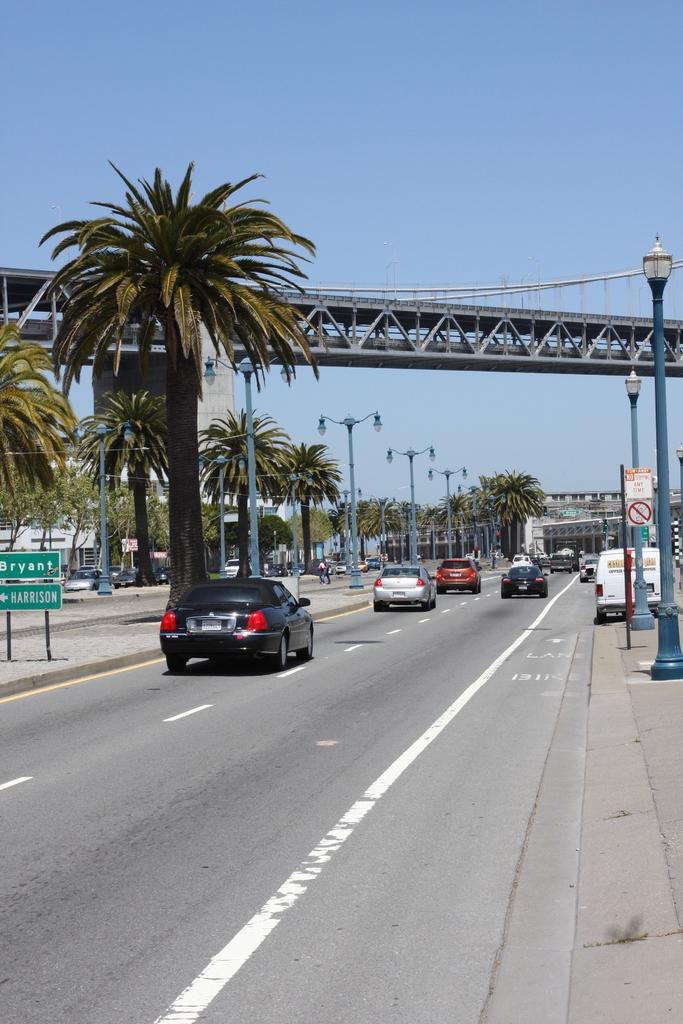What type of natural elements can be seen in the image? There are trees in the image. What type of man-made structures can be seen on the road in the image? There are cars on the road in the image. What type of signs or advertisements might be present in the image? There are boards visible in the image. What type of structures can be seen in the background of the image? There are buildings in the background of the image. What type of vertical structures can be seen in the background of the image? There are poles in the background of the image. What part of the natural environment is visible in the background of the image? The sky is visible in the background of the image. What type of infrastructure is present in the image? There is a bridge in the image. What type of copper material can be seen in the image? There is no copper material present in the image. What type of book is visible on the bridge in the image? There is no book visible in the image, and the bridge is not mentioned as having any books on it. 